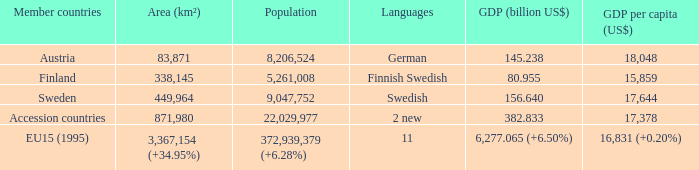Name the area for german 83871.0. 